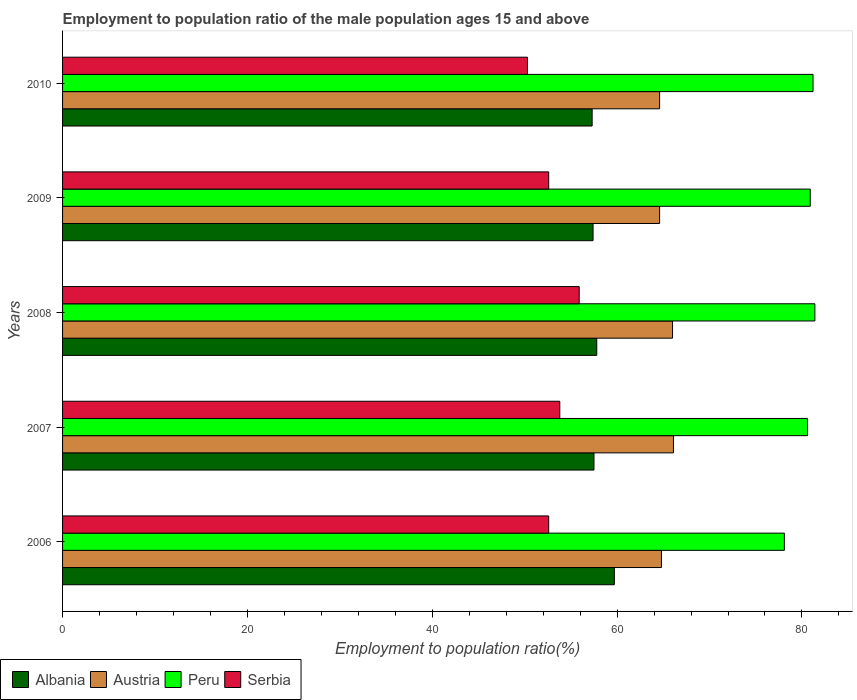How many different coloured bars are there?
Your answer should be compact. 4. How many groups of bars are there?
Provide a short and direct response. 5. Are the number of bars per tick equal to the number of legend labels?
Your response must be concise. Yes. Are the number of bars on each tick of the Y-axis equal?
Provide a succinct answer. Yes. How many bars are there on the 1st tick from the top?
Provide a succinct answer. 4. In how many cases, is the number of bars for a given year not equal to the number of legend labels?
Offer a terse response. 0. What is the employment to population ratio in Albania in 2010?
Offer a terse response. 57.3. Across all years, what is the maximum employment to population ratio in Albania?
Your answer should be very brief. 59.7. Across all years, what is the minimum employment to population ratio in Austria?
Your answer should be very brief. 64.6. What is the total employment to population ratio in Austria in the graph?
Your response must be concise. 326.1. What is the difference between the employment to population ratio in Albania in 2007 and that in 2009?
Make the answer very short. 0.1. What is the difference between the employment to population ratio in Albania in 2006 and the employment to population ratio in Peru in 2010?
Provide a succinct answer. -21.5. What is the average employment to population ratio in Serbia per year?
Provide a succinct answer. 53.04. In the year 2010, what is the difference between the employment to population ratio in Peru and employment to population ratio in Austria?
Offer a terse response. 16.6. What is the ratio of the employment to population ratio in Albania in 2009 to that in 2010?
Provide a short and direct response. 1. Is the employment to population ratio in Serbia in 2009 less than that in 2010?
Your answer should be very brief. No. Is the difference between the employment to population ratio in Peru in 2006 and 2010 greater than the difference between the employment to population ratio in Austria in 2006 and 2010?
Offer a terse response. No. What is the difference between the highest and the second highest employment to population ratio in Serbia?
Offer a very short reply. 2.1. What is the difference between the highest and the lowest employment to population ratio in Serbia?
Provide a short and direct response. 5.6. In how many years, is the employment to population ratio in Austria greater than the average employment to population ratio in Austria taken over all years?
Ensure brevity in your answer.  2. What does the 2nd bar from the top in 2008 represents?
Make the answer very short. Peru. Are all the bars in the graph horizontal?
Make the answer very short. Yes. Are the values on the major ticks of X-axis written in scientific E-notation?
Provide a succinct answer. No. Does the graph contain any zero values?
Keep it short and to the point. No. How are the legend labels stacked?
Give a very brief answer. Horizontal. What is the title of the graph?
Make the answer very short. Employment to population ratio of the male population ages 15 and above. What is the label or title of the X-axis?
Provide a short and direct response. Employment to population ratio(%). What is the Employment to population ratio(%) in Albania in 2006?
Ensure brevity in your answer.  59.7. What is the Employment to population ratio(%) in Austria in 2006?
Your response must be concise. 64.8. What is the Employment to population ratio(%) in Peru in 2006?
Offer a terse response. 78.1. What is the Employment to population ratio(%) in Serbia in 2006?
Give a very brief answer. 52.6. What is the Employment to population ratio(%) in Albania in 2007?
Offer a terse response. 57.5. What is the Employment to population ratio(%) in Austria in 2007?
Provide a short and direct response. 66.1. What is the Employment to population ratio(%) in Peru in 2007?
Give a very brief answer. 80.6. What is the Employment to population ratio(%) of Serbia in 2007?
Offer a very short reply. 53.8. What is the Employment to population ratio(%) in Albania in 2008?
Offer a very short reply. 57.8. What is the Employment to population ratio(%) in Peru in 2008?
Offer a very short reply. 81.4. What is the Employment to population ratio(%) in Serbia in 2008?
Offer a terse response. 55.9. What is the Employment to population ratio(%) of Albania in 2009?
Your answer should be compact. 57.4. What is the Employment to population ratio(%) of Austria in 2009?
Your answer should be compact. 64.6. What is the Employment to population ratio(%) of Peru in 2009?
Make the answer very short. 80.9. What is the Employment to population ratio(%) in Serbia in 2009?
Provide a short and direct response. 52.6. What is the Employment to population ratio(%) of Albania in 2010?
Your response must be concise. 57.3. What is the Employment to population ratio(%) of Austria in 2010?
Provide a succinct answer. 64.6. What is the Employment to population ratio(%) in Peru in 2010?
Give a very brief answer. 81.2. What is the Employment to population ratio(%) of Serbia in 2010?
Offer a terse response. 50.3. Across all years, what is the maximum Employment to population ratio(%) of Albania?
Offer a terse response. 59.7. Across all years, what is the maximum Employment to population ratio(%) of Austria?
Provide a short and direct response. 66.1. Across all years, what is the maximum Employment to population ratio(%) of Peru?
Keep it short and to the point. 81.4. Across all years, what is the maximum Employment to population ratio(%) in Serbia?
Give a very brief answer. 55.9. Across all years, what is the minimum Employment to population ratio(%) in Albania?
Offer a terse response. 57.3. Across all years, what is the minimum Employment to population ratio(%) in Austria?
Provide a short and direct response. 64.6. Across all years, what is the minimum Employment to population ratio(%) of Peru?
Make the answer very short. 78.1. Across all years, what is the minimum Employment to population ratio(%) of Serbia?
Offer a very short reply. 50.3. What is the total Employment to population ratio(%) in Albania in the graph?
Ensure brevity in your answer.  289.7. What is the total Employment to population ratio(%) of Austria in the graph?
Your response must be concise. 326.1. What is the total Employment to population ratio(%) of Peru in the graph?
Your answer should be compact. 402.2. What is the total Employment to population ratio(%) of Serbia in the graph?
Ensure brevity in your answer.  265.2. What is the difference between the Employment to population ratio(%) of Peru in 2006 and that in 2007?
Ensure brevity in your answer.  -2.5. What is the difference between the Employment to population ratio(%) in Austria in 2006 and that in 2008?
Your response must be concise. -1.2. What is the difference between the Employment to population ratio(%) in Peru in 2006 and that in 2008?
Offer a terse response. -3.3. What is the difference between the Employment to population ratio(%) of Austria in 2006 and that in 2009?
Your answer should be compact. 0.2. What is the difference between the Employment to population ratio(%) in Serbia in 2006 and that in 2009?
Keep it short and to the point. 0. What is the difference between the Employment to population ratio(%) of Austria in 2006 and that in 2010?
Your answer should be very brief. 0.2. What is the difference between the Employment to population ratio(%) in Peru in 2006 and that in 2010?
Your answer should be compact. -3.1. What is the difference between the Employment to population ratio(%) of Serbia in 2006 and that in 2010?
Ensure brevity in your answer.  2.3. What is the difference between the Employment to population ratio(%) of Albania in 2007 and that in 2008?
Give a very brief answer. -0.3. What is the difference between the Employment to population ratio(%) of Serbia in 2007 and that in 2008?
Offer a very short reply. -2.1. What is the difference between the Employment to population ratio(%) of Peru in 2007 and that in 2009?
Your response must be concise. -0.3. What is the difference between the Employment to population ratio(%) of Serbia in 2007 and that in 2009?
Provide a short and direct response. 1.2. What is the difference between the Employment to population ratio(%) in Austria in 2007 and that in 2010?
Offer a terse response. 1.5. What is the difference between the Employment to population ratio(%) in Peru in 2007 and that in 2010?
Offer a terse response. -0.6. What is the difference between the Employment to population ratio(%) in Albania in 2008 and that in 2009?
Offer a very short reply. 0.4. What is the difference between the Employment to population ratio(%) of Albania in 2008 and that in 2010?
Offer a very short reply. 0.5. What is the difference between the Employment to population ratio(%) of Austria in 2008 and that in 2010?
Give a very brief answer. 1.4. What is the difference between the Employment to population ratio(%) in Peru in 2008 and that in 2010?
Offer a terse response. 0.2. What is the difference between the Employment to population ratio(%) of Serbia in 2009 and that in 2010?
Make the answer very short. 2.3. What is the difference between the Employment to population ratio(%) in Albania in 2006 and the Employment to population ratio(%) in Peru in 2007?
Make the answer very short. -20.9. What is the difference between the Employment to population ratio(%) in Austria in 2006 and the Employment to population ratio(%) in Peru in 2007?
Offer a terse response. -15.8. What is the difference between the Employment to population ratio(%) of Austria in 2006 and the Employment to population ratio(%) of Serbia in 2007?
Offer a terse response. 11. What is the difference between the Employment to population ratio(%) of Peru in 2006 and the Employment to population ratio(%) of Serbia in 2007?
Offer a very short reply. 24.3. What is the difference between the Employment to population ratio(%) of Albania in 2006 and the Employment to population ratio(%) of Peru in 2008?
Ensure brevity in your answer.  -21.7. What is the difference between the Employment to population ratio(%) in Albania in 2006 and the Employment to population ratio(%) in Serbia in 2008?
Offer a terse response. 3.8. What is the difference between the Employment to population ratio(%) of Austria in 2006 and the Employment to population ratio(%) of Peru in 2008?
Your answer should be very brief. -16.6. What is the difference between the Employment to population ratio(%) of Austria in 2006 and the Employment to population ratio(%) of Serbia in 2008?
Give a very brief answer. 8.9. What is the difference between the Employment to population ratio(%) of Albania in 2006 and the Employment to population ratio(%) of Austria in 2009?
Provide a succinct answer. -4.9. What is the difference between the Employment to population ratio(%) of Albania in 2006 and the Employment to population ratio(%) of Peru in 2009?
Provide a short and direct response. -21.2. What is the difference between the Employment to population ratio(%) in Albania in 2006 and the Employment to population ratio(%) in Serbia in 2009?
Provide a succinct answer. 7.1. What is the difference between the Employment to population ratio(%) in Austria in 2006 and the Employment to population ratio(%) in Peru in 2009?
Your response must be concise. -16.1. What is the difference between the Employment to population ratio(%) of Austria in 2006 and the Employment to population ratio(%) of Serbia in 2009?
Offer a terse response. 12.2. What is the difference between the Employment to population ratio(%) in Peru in 2006 and the Employment to population ratio(%) in Serbia in 2009?
Keep it short and to the point. 25.5. What is the difference between the Employment to population ratio(%) of Albania in 2006 and the Employment to population ratio(%) of Peru in 2010?
Your answer should be very brief. -21.5. What is the difference between the Employment to population ratio(%) of Albania in 2006 and the Employment to population ratio(%) of Serbia in 2010?
Make the answer very short. 9.4. What is the difference between the Employment to population ratio(%) of Austria in 2006 and the Employment to population ratio(%) of Peru in 2010?
Make the answer very short. -16.4. What is the difference between the Employment to population ratio(%) of Peru in 2006 and the Employment to population ratio(%) of Serbia in 2010?
Ensure brevity in your answer.  27.8. What is the difference between the Employment to population ratio(%) of Albania in 2007 and the Employment to population ratio(%) of Austria in 2008?
Ensure brevity in your answer.  -8.5. What is the difference between the Employment to population ratio(%) of Albania in 2007 and the Employment to population ratio(%) of Peru in 2008?
Ensure brevity in your answer.  -23.9. What is the difference between the Employment to population ratio(%) of Austria in 2007 and the Employment to population ratio(%) of Peru in 2008?
Provide a succinct answer. -15.3. What is the difference between the Employment to population ratio(%) in Austria in 2007 and the Employment to population ratio(%) in Serbia in 2008?
Ensure brevity in your answer.  10.2. What is the difference between the Employment to population ratio(%) of Peru in 2007 and the Employment to population ratio(%) of Serbia in 2008?
Offer a terse response. 24.7. What is the difference between the Employment to population ratio(%) of Albania in 2007 and the Employment to population ratio(%) of Austria in 2009?
Your response must be concise. -7.1. What is the difference between the Employment to population ratio(%) of Albania in 2007 and the Employment to population ratio(%) of Peru in 2009?
Offer a very short reply. -23.4. What is the difference between the Employment to population ratio(%) of Austria in 2007 and the Employment to population ratio(%) of Peru in 2009?
Ensure brevity in your answer.  -14.8. What is the difference between the Employment to population ratio(%) in Albania in 2007 and the Employment to population ratio(%) in Austria in 2010?
Make the answer very short. -7.1. What is the difference between the Employment to population ratio(%) in Albania in 2007 and the Employment to population ratio(%) in Peru in 2010?
Offer a terse response. -23.7. What is the difference between the Employment to population ratio(%) of Austria in 2007 and the Employment to population ratio(%) of Peru in 2010?
Provide a short and direct response. -15.1. What is the difference between the Employment to population ratio(%) in Peru in 2007 and the Employment to population ratio(%) in Serbia in 2010?
Provide a succinct answer. 30.3. What is the difference between the Employment to population ratio(%) of Albania in 2008 and the Employment to population ratio(%) of Peru in 2009?
Provide a short and direct response. -23.1. What is the difference between the Employment to population ratio(%) in Austria in 2008 and the Employment to population ratio(%) in Peru in 2009?
Ensure brevity in your answer.  -14.9. What is the difference between the Employment to population ratio(%) in Austria in 2008 and the Employment to population ratio(%) in Serbia in 2009?
Your response must be concise. 13.4. What is the difference between the Employment to population ratio(%) in Peru in 2008 and the Employment to population ratio(%) in Serbia in 2009?
Provide a succinct answer. 28.8. What is the difference between the Employment to population ratio(%) of Albania in 2008 and the Employment to population ratio(%) of Austria in 2010?
Make the answer very short. -6.8. What is the difference between the Employment to population ratio(%) of Albania in 2008 and the Employment to population ratio(%) of Peru in 2010?
Your response must be concise. -23.4. What is the difference between the Employment to population ratio(%) in Albania in 2008 and the Employment to population ratio(%) in Serbia in 2010?
Offer a terse response. 7.5. What is the difference between the Employment to population ratio(%) of Austria in 2008 and the Employment to population ratio(%) of Peru in 2010?
Offer a very short reply. -15.2. What is the difference between the Employment to population ratio(%) in Austria in 2008 and the Employment to population ratio(%) in Serbia in 2010?
Your answer should be compact. 15.7. What is the difference between the Employment to population ratio(%) in Peru in 2008 and the Employment to population ratio(%) in Serbia in 2010?
Your answer should be very brief. 31.1. What is the difference between the Employment to population ratio(%) in Albania in 2009 and the Employment to population ratio(%) in Austria in 2010?
Keep it short and to the point. -7.2. What is the difference between the Employment to population ratio(%) of Albania in 2009 and the Employment to population ratio(%) of Peru in 2010?
Give a very brief answer. -23.8. What is the difference between the Employment to population ratio(%) of Austria in 2009 and the Employment to population ratio(%) of Peru in 2010?
Offer a very short reply. -16.6. What is the difference between the Employment to population ratio(%) in Peru in 2009 and the Employment to population ratio(%) in Serbia in 2010?
Your answer should be compact. 30.6. What is the average Employment to population ratio(%) in Albania per year?
Ensure brevity in your answer.  57.94. What is the average Employment to population ratio(%) in Austria per year?
Your answer should be very brief. 65.22. What is the average Employment to population ratio(%) in Peru per year?
Make the answer very short. 80.44. What is the average Employment to population ratio(%) of Serbia per year?
Your answer should be compact. 53.04. In the year 2006, what is the difference between the Employment to population ratio(%) of Albania and Employment to population ratio(%) of Austria?
Your response must be concise. -5.1. In the year 2006, what is the difference between the Employment to population ratio(%) of Albania and Employment to population ratio(%) of Peru?
Offer a very short reply. -18.4. In the year 2006, what is the difference between the Employment to population ratio(%) of Albania and Employment to population ratio(%) of Serbia?
Provide a succinct answer. 7.1. In the year 2006, what is the difference between the Employment to population ratio(%) in Austria and Employment to population ratio(%) in Peru?
Provide a short and direct response. -13.3. In the year 2006, what is the difference between the Employment to population ratio(%) in Austria and Employment to population ratio(%) in Serbia?
Provide a succinct answer. 12.2. In the year 2007, what is the difference between the Employment to population ratio(%) in Albania and Employment to population ratio(%) in Peru?
Keep it short and to the point. -23.1. In the year 2007, what is the difference between the Employment to population ratio(%) in Albania and Employment to population ratio(%) in Serbia?
Your response must be concise. 3.7. In the year 2007, what is the difference between the Employment to population ratio(%) in Austria and Employment to population ratio(%) in Serbia?
Offer a very short reply. 12.3. In the year 2007, what is the difference between the Employment to population ratio(%) of Peru and Employment to population ratio(%) of Serbia?
Provide a short and direct response. 26.8. In the year 2008, what is the difference between the Employment to population ratio(%) in Albania and Employment to population ratio(%) in Peru?
Keep it short and to the point. -23.6. In the year 2008, what is the difference between the Employment to population ratio(%) of Austria and Employment to population ratio(%) of Peru?
Ensure brevity in your answer.  -15.4. In the year 2008, what is the difference between the Employment to population ratio(%) in Peru and Employment to population ratio(%) in Serbia?
Offer a very short reply. 25.5. In the year 2009, what is the difference between the Employment to population ratio(%) of Albania and Employment to population ratio(%) of Austria?
Keep it short and to the point. -7.2. In the year 2009, what is the difference between the Employment to population ratio(%) of Albania and Employment to population ratio(%) of Peru?
Provide a succinct answer. -23.5. In the year 2009, what is the difference between the Employment to population ratio(%) of Austria and Employment to population ratio(%) of Peru?
Offer a terse response. -16.3. In the year 2009, what is the difference between the Employment to population ratio(%) in Austria and Employment to population ratio(%) in Serbia?
Your response must be concise. 12. In the year 2009, what is the difference between the Employment to population ratio(%) of Peru and Employment to population ratio(%) of Serbia?
Keep it short and to the point. 28.3. In the year 2010, what is the difference between the Employment to population ratio(%) of Albania and Employment to population ratio(%) of Peru?
Provide a succinct answer. -23.9. In the year 2010, what is the difference between the Employment to population ratio(%) in Albania and Employment to population ratio(%) in Serbia?
Give a very brief answer. 7. In the year 2010, what is the difference between the Employment to population ratio(%) of Austria and Employment to population ratio(%) of Peru?
Offer a very short reply. -16.6. In the year 2010, what is the difference between the Employment to population ratio(%) of Austria and Employment to population ratio(%) of Serbia?
Ensure brevity in your answer.  14.3. In the year 2010, what is the difference between the Employment to population ratio(%) of Peru and Employment to population ratio(%) of Serbia?
Your answer should be very brief. 30.9. What is the ratio of the Employment to population ratio(%) of Albania in 2006 to that in 2007?
Make the answer very short. 1.04. What is the ratio of the Employment to population ratio(%) of Austria in 2006 to that in 2007?
Provide a short and direct response. 0.98. What is the ratio of the Employment to population ratio(%) of Peru in 2006 to that in 2007?
Provide a short and direct response. 0.97. What is the ratio of the Employment to population ratio(%) in Serbia in 2006 to that in 2007?
Make the answer very short. 0.98. What is the ratio of the Employment to population ratio(%) in Albania in 2006 to that in 2008?
Your answer should be very brief. 1.03. What is the ratio of the Employment to population ratio(%) in Austria in 2006 to that in 2008?
Offer a terse response. 0.98. What is the ratio of the Employment to population ratio(%) of Peru in 2006 to that in 2008?
Offer a very short reply. 0.96. What is the ratio of the Employment to population ratio(%) in Serbia in 2006 to that in 2008?
Your answer should be compact. 0.94. What is the ratio of the Employment to population ratio(%) in Albania in 2006 to that in 2009?
Provide a short and direct response. 1.04. What is the ratio of the Employment to population ratio(%) of Peru in 2006 to that in 2009?
Your answer should be very brief. 0.97. What is the ratio of the Employment to population ratio(%) in Serbia in 2006 to that in 2009?
Make the answer very short. 1. What is the ratio of the Employment to population ratio(%) in Albania in 2006 to that in 2010?
Provide a succinct answer. 1.04. What is the ratio of the Employment to population ratio(%) of Austria in 2006 to that in 2010?
Provide a short and direct response. 1. What is the ratio of the Employment to population ratio(%) of Peru in 2006 to that in 2010?
Your answer should be compact. 0.96. What is the ratio of the Employment to population ratio(%) in Serbia in 2006 to that in 2010?
Your response must be concise. 1.05. What is the ratio of the Employment to population ratio(%) of Albania in 2007 to that in 2008?
Keep it short and to the point. 0.99. What is the ratio of the Employment to population ratio(%) of Austria in 2007 to that in 2008?
Offer a terse response. 1. What is the ratio of the Employment to population ratio(%) of Peru in 2007 to that in 2008?
Offer a very short reply. 0.99. What is the ratio of the Employment to population ratio(%) of Serbia in 2007 to that in 2008?
Your answer should be very brief. 0.96. What is the ratio of the Employment to population ratio(%) in Albania in 2007 to that in 2009?
Offer a very short reply. 1. What is the ratio of the Employment to population ratio(%) of Austria in 2007 to that in 2009?
Keep it short and to the point. 1.02. What is the ratio of the Employment to population ratio(%) of Peru in 2007 to that in 2009?
Give a very brief answer. 1. What is the ratio of the Employment to population ratio(%) in Serbia in 2007 to that in 2009?
Ensure brevity in your answer.  1.02. What is the ratio of the Employment to population ratio(%) of Austria in 2007 to that in 2010?
Provide a short and direct response. 1.02. What is the ratio of the Employment to population ratio(%) of Peru in 2007 to that in 2010?
Your answer should be very brief. 0.99. What is the ratio of the Employment to population ratio(%) in Serbia in 2007 to that in 2010?
Keep it short and to the point. 1.07. What is the ratio of the Employment to population ratio(%) of Austria in 2008 to that in 2009?
Make the answer very short. 1.02. What is the ratio of the Employment to population ratio(%) of Serbia in 2008 to that in 2009?
Provide a succinct answer. 1.06. What is the ratio of the Employment to population ratio(%) in Albania in 2008 to that in 2010?
Your response must be concise. 1.01. What is the ratio of the Employment to population ratio(%) of Austria in 2008 to that in 2010?
Give a very brief answer. 1.02. What is the ratio of the Employment to population ratio(%) of Peru in 2008 to that in 2010?
Offer a very short reply. 1. What is the ratio of the Employment to population ratio(%) of Serbia in 2008 to that in 2010?
Ensure brevity in your answer.  1.11. What is the ratio of the Employment to population ratio(%) in Albania in 2009 to that in 2010?
Ensure brevity in your answer.  1. What is the ratio of the Employment to population ratio(%) in Peru in 2009 to that in 2010?
Offer a very short reply. 1. What is the ratio of the Employment to population ratio(%) in Serbia in 2009 to that in 2010?
Provide a succinct answer. 1.05. What is the difference between the highest and the second highest Employment to population ratio(%) of Austria?
Ensure brevity in your answer.  0.1. What is the difference between the highest and the second highest Employment to population ratio(%) of Serbia?
Ensure brevity in your answer.  2.1. 